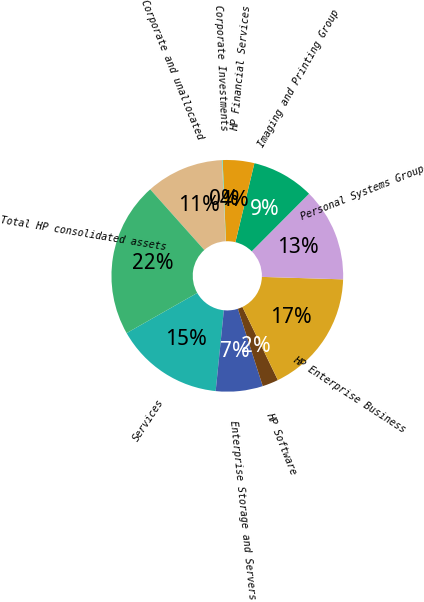<chart> <loc_0><loc_0><loc_500><loc_500><pie_chart><fcel>Services<fcel>Enterprise Storage and Servers<fcel>HP Software<fcel>HP Enterprise Business<fcel>Personal Systems Group<fcel>Imaging and Printing Group<fcel>HP Financial Services<fcel>Corporate Investments<fcel>Corporate and unallocated<fcel>Total HP consolidated assets<nl><fcel>15.17%<fcel>6.55%<fcel>2.24%<fcel>17.33%<fcel>13.02%<fcel>8.71%<fcel>4.4%<fcel>0.09%<fcel>10.86%<fcel>21.64%<nl></chart> 